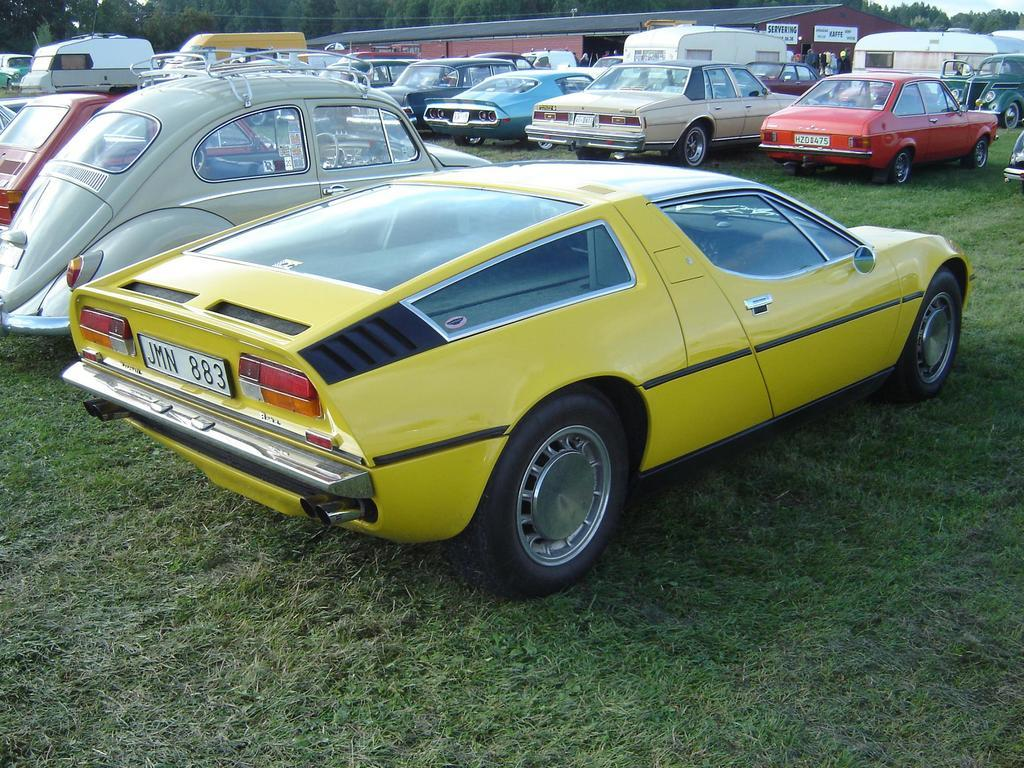What is located on the grass in the image? There are vehicles on the grass in the image. What can be seen on the vehicles? The vehicles have number plates. What can be seen in the distance in the image? There are trees visible in the background of the image. What hobbies does your aunt have, as seen in the image? There is no mention of an aunt or any hobbies in the image; it features vehicles on the grass with number plates and trees in the background. 